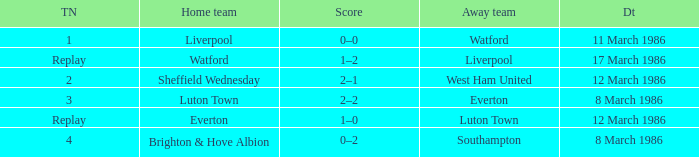What was the tie resulting from Sheffield Wednesday's game? 2.0. 